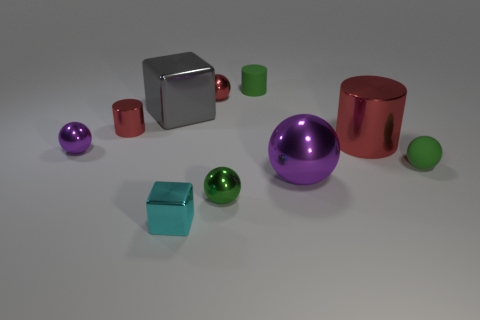How many large gray things have the same material as the tiny red sphere?
Make the answer very short. 1. How many objects are either big metallic blocks or large red cylinders?
Your answer should be compact. 2. Are there any tiny purple things that are left of the red metallic cylinder that is behind the big red metallic thing?
Provide a succinct answer. Yes. Are there more big red objects left of the green rubber ball than red metallic spheres in front of the big purple shiny sphere?
Provide a succinct answer. Yes. What material is the cylinder that is the same color as the matte ball?
Provide a succinct answer. Rubber. How many rubber cylinders have the same color as the small metal cube?
Keep it short and to the point. 0. Do the metal cylinder that is to the right of the small matte cylinder and the sphere that is behind the small red metallic cylinder have the same color?
Offer a terse response. Yes. There is a big purple metal ball; are there any red metal cylinders to the left of it?
Your answer should be very brief. Yes. What is the cyan object made of?
Provide a short and direct response. Metal. The large metallic object that is left of the small green matte cylinder has what shape?
Offer a very short reply. Cube. 